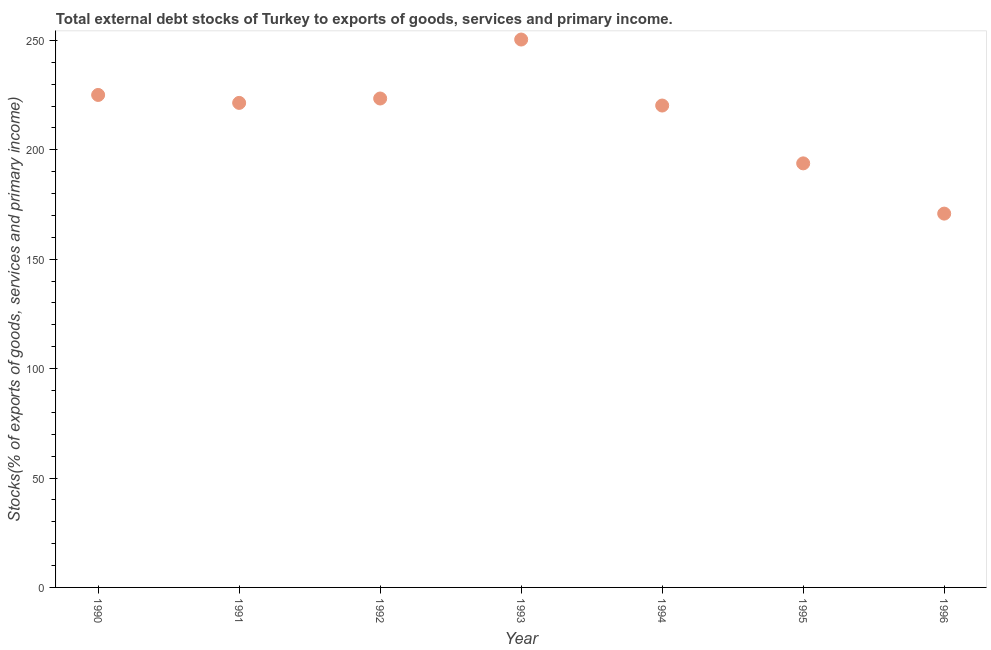What is the external debt stocks in 1992?
Your answer should be very brief. 223.44. Across all years, what is the maximum external debt stocks?
Your answer should be compact. 250.4. Across all years, what is the minimum external debt stocks?
Give a very brief answer. 170.84. In which year was the external debt stocks minimum?
Your response must be concise. 1996. What is the sum of the external debt stocks?
Your answer should be compact. 1505.24. What is the difference between the external debt stocks in 1993 and 1994?
Your answer should be compact. 30.16. What is the average external debt stocks per year?
Make the answer very short. 215.03. What is the median external debt stocks?
Your answer should be compact. 221.44. What is the ratio of the external debt stocks in 1991 to that in 1994?
Offer a terse response. 1.01. Is the difference between the external debt stocks in 1990 and 1996 greater than the difference between any two years?
Your answer should be very brief. No. What is the difference between the highest and the second highest external debt stocks?
Your response must be concise. 25.33. What is the difference between the highest and the lowest external debt stocks?
Keep it short and to the point. 79.56. Does the external debt stocks monotonically increase over the years?
Give a very brief answer. No. How many years are there in the graph?
Offer a very short reply. 7. Does the graph contain any zero values?
Keep it short and to the point. No. Does the graph contain grids?
Your response must be concise. No. What is the title of the graph?
Offer a very short reply. Total external debt stocks of Turkey to exports of goods, services and primary income. What is the label or title of the Y-axis?
Give a very brief answer. Stocks(% of exports of goods, services and primary income). What is the Stocks(% of exports of goods, services and primary income) in 1990?
Offer a very short reply. 225.07. What is the Stocks(% of exports of goods, services and primary income) in 1991?
Provide a succinct answer. 221.44. What is the Stocks(% of exports of goods, services and primary income) in 1992?
Your answer should be compact. 223.44. What is the Stocks(% of exports of goods, services and primary income) in 1993?
Your answer should be compact. 250.4. What is the Stocks(% of exports of goods, services and primary income) in 1994?
Your answer should be compact. 220.24. What is the Stocks(% of exports of goods, services and primary income) in 1995?
Provide a short and direct response. 193.8. What is the Stocks(% of exports of goods, services and primary income) in 1996?
Your answer should be very brief. 170.84. What is the difference between the Stocks(% of exports of goods, services and primary income) in 1990 and 1991?
Provide a short and direct response. 3.64. What is the difference between the Stocks(% of exports of goods, services and primary income) in 1990 and 1992?
Give a very brief answer. 1.63. What is the difference between the Stocks(% of exports of goods, services and primary income) in 1990 and 1993?
Your answer should be very brief. -25.33. What is the difference between the Stocks(% of exports of goods, services and primary income) in 1990 and 1994?
Keep it short and to the point. 4.84. What is the difference between the Stocks(% of exports of goods, services and primary income) in 1990 and 1995?
Provide a succinct answer. 31.27. What is the difference between the Stocks(% of exports of goods, services and primary income) in 1990 and 1996?
Your answer should be compact. 54.23. What is the difference between the Stocks(% of exports of goods, services and primary income) in 1991 and 1992?
Make the answer very short. -2.01. What is the difference between the Stocks(% of exports of goods, services and primary income) in 1991 and 1993?
Offer a terse response. -28.96. What is the difference between the Stocks(% of exports of goods, services and primary income) in 1991 and 1994?
Give a very brief answer. 1.2. What is the difference between the Stocks(% of exports of goods, services and primary income) in 1991 and 1995?
Your answer should be very brief. 27.64. What is the difference between the Stocks(% of exports of goods, services and primary income) in 1991 and 1996?
Offer a terse response. 50.6. What is the difference between the Stocks(% of exports of goods, services and primary income) in 1992 and 1993?
Your answer should be compact. -26.96. What is the difference between the Stocks(% of exports of goods, services and primary income) in 1992 and 1994?
Give a very brief answer. 3.21. What is the difference between the Stocks(% of exports of goods, services and primary income) in 1992 and 1995?
Provide a succinct answer. 29.64. What is the difference between the Stocks(% of exports of goods, services and primary income) in 1992 and 1996?
Give a very brief answer. 52.6. What is the difference between the Stocks(% of exports of goods, services and primary income) in 1993 and 1994?
Provide a succinct answer. 30.16. What is the difference between the Stocks(% of exports of goods, services and primary income) in 1993 and 1995?
Your answer should be very brief. 56.6. What is the difference between the Stocks(% of exports of goods, services and primary income) in 1993 and 1996?
Make the answer very short. 79.56. What is the difference between the Stocks(% of exports of goods, services and primary income) in 1994 and 1995?
Keep it short and to the point. 26.43. What is the difference between the Stocks(% of exports of goods, services and primary income) in 1994 and 1996?
Your response must be concise. 49.39. What is the difference between the Stocks(% of exports of goods, services and primary income) in 1995 and 1996?
Your answer should be very brief. 22.96. What is the ratio of the Stocks(% of exports of goods, services and primary income) in 1990 to that in 1992?
Make the answer very short. 1.01. What is the ratio of the Stocks(% of exports of goods, services and primary income) in 1990 to that in 1993?
Your response must be concise. 0.9. What is the ratio of the Stocks(% of exports of goods, services and primary income) in 1990 to that in 1995?
Your answer should be compact. 1.16. What is the ratio of the Stocks(% of exports of goods, services and primary income) in 1990 to that in 1996?
Provide a succinct answer. 1.32. What is the ratio of the Stocks(% of exports of goods, services and primary income) in 1991 to that in 1992?
Your response must be concise. 0.99. What is the ratio of the Stocks(% of exports of goods, services and primary income) in 1991 to that in 1993?
Offer a very short reply. 0.88. What is the ratio of the Stocks(% of exports of goods, services and primary income) in 1991 to that in 1994?
Ensure brevity in your answer.  1. What is the ratio of the Stocks(% of exports of goods, services and primary income) in 1991 to that in 1995?
Your answer should be compact. 1.14. What is the ratio of the Stocks(% of exports of goods, services and primary income) in 1991 to that in 1996?
Keep it short and to the point. 1.3. What is the ratio of the Stocks(% of exports of goods, services and primary income) in 1992 to that in 1993?
Make the answer very short. 0.89. What is the ratio of the Stocks(% of exports of goods, services and primary income) in 1992 to that in 1994?
Offer a terse response. 1.01. What is the ratio of the Stocks(% of exports of goods, services and primary income) in 1992 to that in 1995?
Ensure brevity in your answer.  1.15. What is the ratio of the Stocks(% of exports of goods, services and primary income) in 1992 to that in 1996?
Provide a succinct answer. 1.31. What is the ratio of the Stocks(% of exports of goods, services and primary income) in 1993 to that in 1994?
Your answer should be very brief. 1.14. What is the ratio of the Stocks(% of exports of goods, services and primary income) in 1993 to that in 1995?
Your answer should be very brief. 1.29. What is the ratio of the Stocks(% of exports of goods, services and primary income) in 1993 to that in 1996?
Offer a terse response. 1.47. What is the ratio of the Stocks(% of exports of goods, services and primary income) in 1994 to that in 1995?
Your response must be concise. 1.14. What is the ratio of the Stocks(% of exports of goods, services and primary income) in 1994 to that in 1996?
Offer a very short reply. 1.29. What is the ratio of the Stocks(% of exports of goods, services and primary income) in 1995 to that in 1996?
Keep it short and to the point. 1.13. 